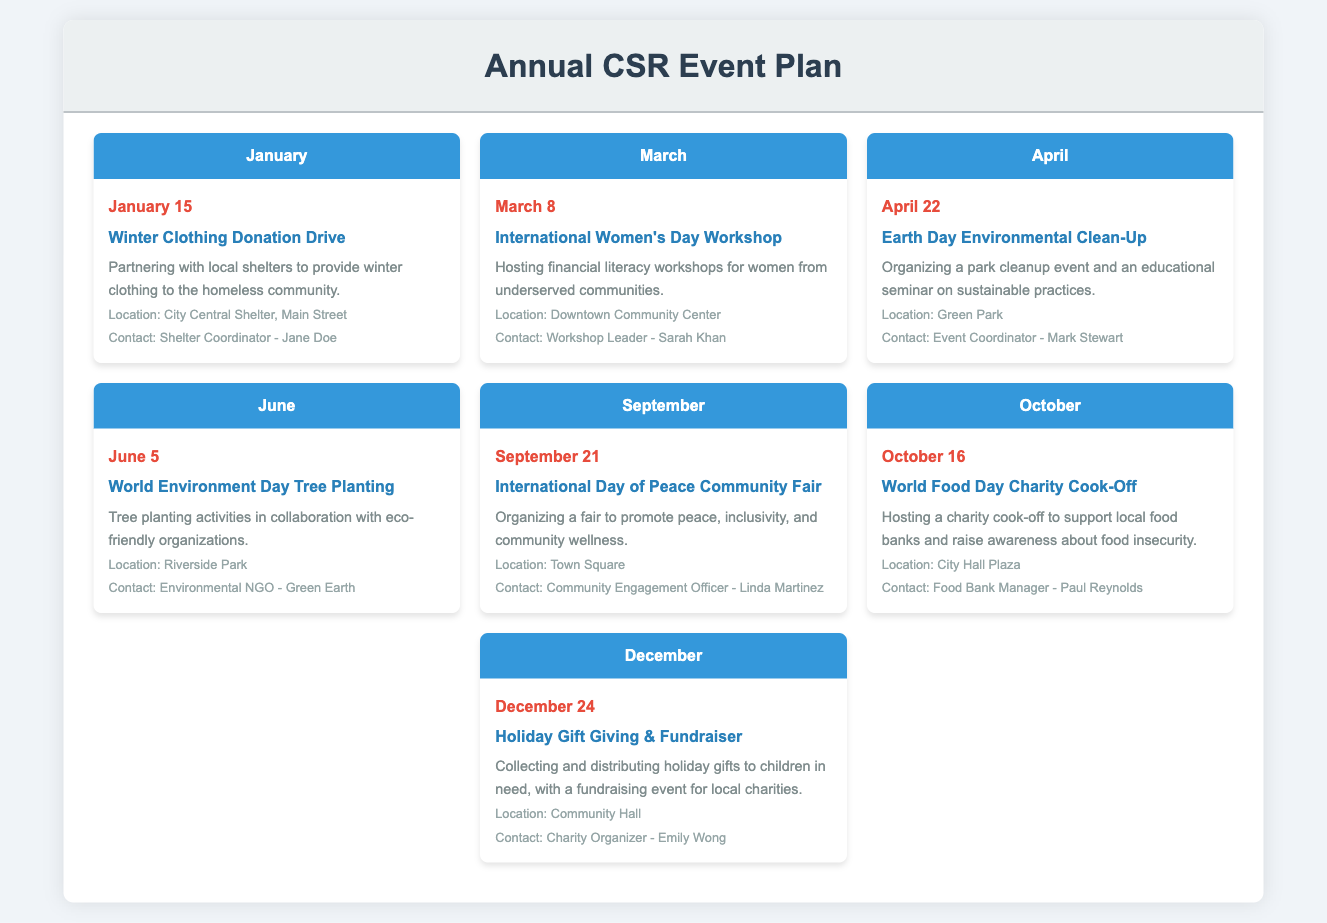What is the date of the Winter Clothing Donation Drive? The date is specified under the January section of the document.
Answer: January 15 Who is the contact person for the International Women's Day Workshop? The document lists a workshop leader as the contact, found in the March section.
Answer: Sarah Khan What event is scheduled for April 22? The event title is located in the April section, which details upcoming activities.
Answer: Earth Day Environmental Clean-Up Where is the World Environment Day Tree Planting taking place? The location is detailed in the June section of the document.
Answer: Riverside Park How many events are planned for December? The events for each month are listed, and December has one specific event noted.
Answer: 1 What is the main theme of the September event? The theme is outlined in the event description in the September section.
Answer: Peace, inclusivity, and community wellness Who is organizing the Holiday Gift Giving & Fundraiser? The charity organizer's name is provided in the December section.
Answer: Emily Wong Which event involves a charity cook-off? The title of the event is found under the October section describing that initiative.
Answer: World Food Day Charity Cook-Off 